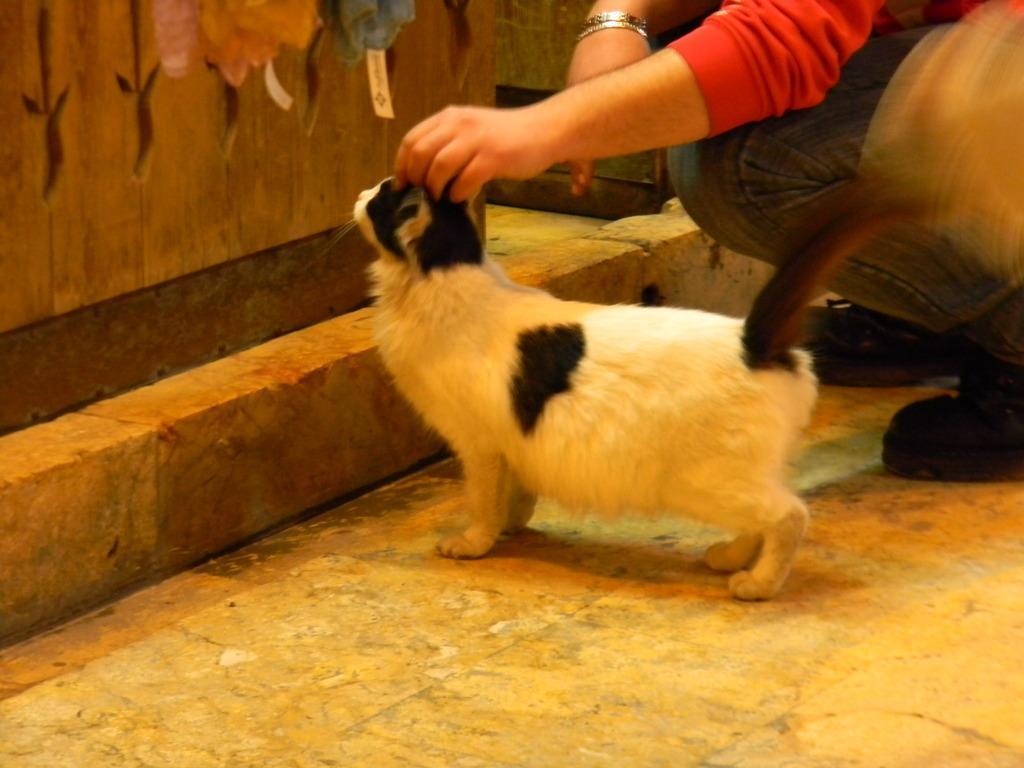Could you give a brief overview of what you see in this image? In this image we can see a cat on the surface. We can also see a person and also the wooden wall. 